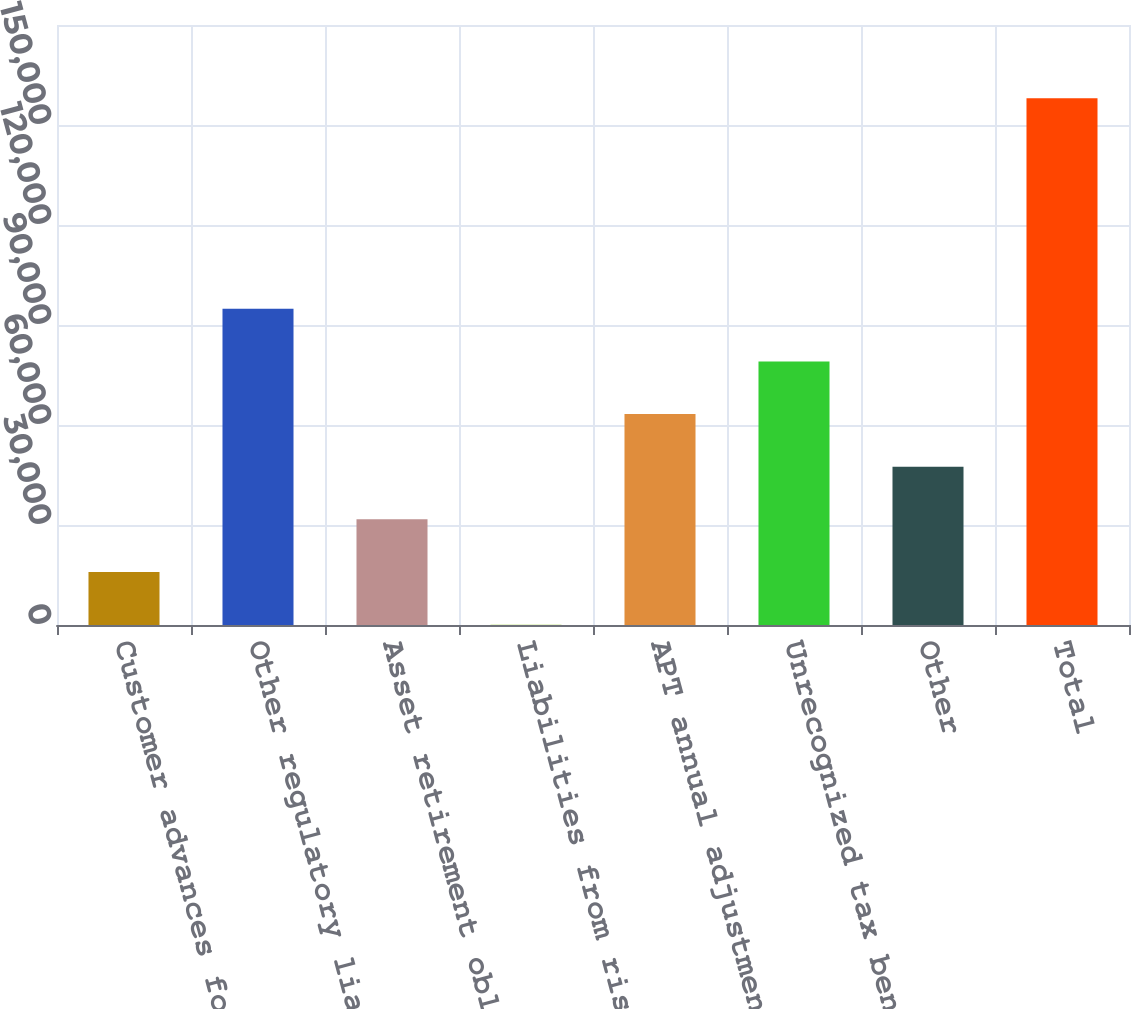<chart> <loc_0><loc_0><loc_500><loc_500><bar_chart><fcel>Customer advances for<fcel>Other regulatory liabilities<fcel>Asset retirement obligation<fcel>Liabilities from risk<fcel>APT annual adjustment<fcel>Unrecognized tax benefits<fcel>Other<fcel>Total<nl><fcel>15895.5<fcel>94858<fcel>31688<fcel>103<fcel>63273<fcel>79065.5<fcel>47480.5<fcel>158028<nl></chart> 